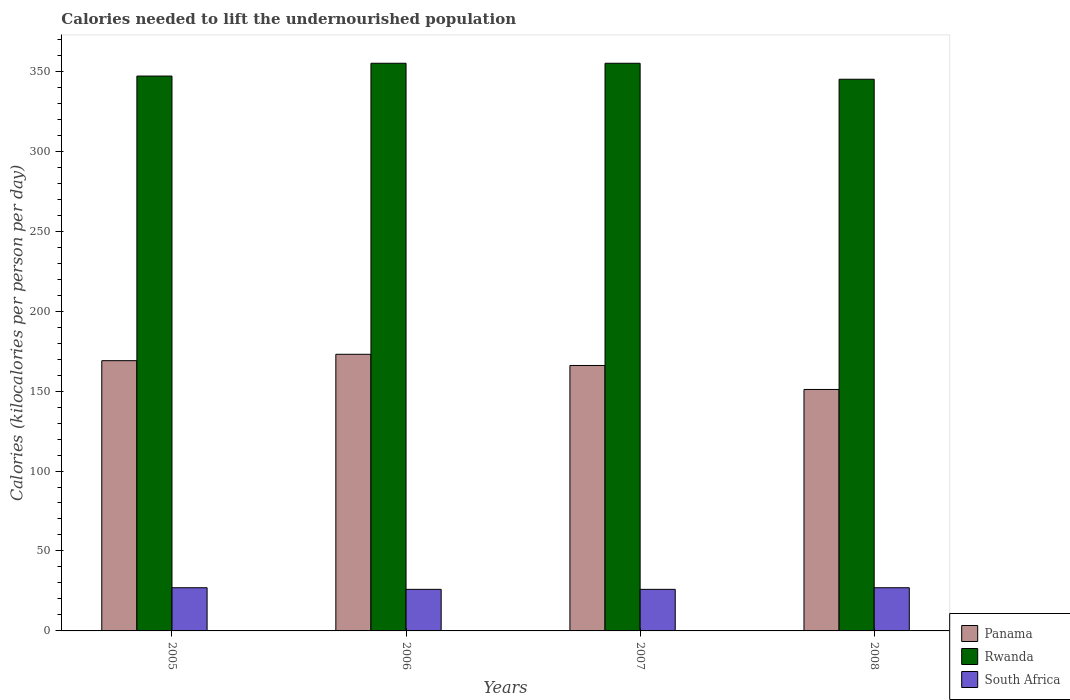How many different coloured bars are there?
Keep it short and to the point. 3. Are the number of bars on each tick of the X-axis equal?
Offer a terse response. Yes. What is the total calories needed to lift the undernourished population in Panama in 2008?
Keep it short and to the point. 151. Across all years, what is the maximum total calories needed to lift the undernourished population in Rwanda?
Keep it short and to the point. 355. Across all years, what is the minimum total calories needed to lift the undernourished population in Rwanda?
Your answer should be compact. 345. In which year was the total calories needed to lift the undernourished population in Rwanda maximum?
Make the answer very short. 2006. What is the total total calories needed to lift the undernourished population in Rwanda in the graph?
Offer a very short reply. 1402. What is the difference between the total calories needed to lift the undernourished population in Rwanda in 2005 and that in 2006?
Make the answer very short. -8. What is the difference between the total calories needed to lift the undernourished population in Panama in 2008 and the total calories needed to lift the undernourished population in Rwanda in 2005?
Your answer should be very brief. -196. What is the average total calories needed to lift the undernourished population in Panama per year?
Make the answer very short. 164.75. In the year 2005, what is the difference between the total calories needed to lift the undernourished population in South Africa and total calories needed to lift the undernourished population in Rwanda?
Offer a terse response. -320. What is the ratio of the total calories needed to lift the undernourished population in South Africa in 2007 to that in 2008?
Provide a short and direct response. 0.96. What is the difference between the highest and the second highest total calories needed to lift the undernourished population in Rwanda?
Offer a very short reply. 0. What is the difference between the highest and the lowest total calories needed to lift the undernourished population in Panama?
Your answer should be very brief. 22. Is the sum of the total calories needed to lift the undernourished population in Panama in 2005 and 2007 greater than the maximum total calories needed to lift the undernourished population in Rwanda across all years?
Keep it short and to the point. No. What does the 2nd bar from the left in 2005 represents?
Give a very brief answer. Rwanda. What does the 2nd bar from the right in 2005 represents?
Ensure brevity in your answer.  Rwanda. Is it the case that in every year, the sum of the total calories needed to lift the undernourished population in Rwanda and total calories needed to lift the undernourished population in Panama is greater than the total calories needed to lift the undernourished population in South Africa?
Keep it short and to the point. Yes. How many bars are there?
Make the answer very short. 12. Are all the bars in the graph horizontal?
Make the answer very short. No. How many years are there in the graph?
Offer a very short reply. 4. What is the difference between two consecutive major ticks on the Y-axis?
Provide a short and direct response. 50. Are the values on the major ticks of Y-axis written in scientific E-notation?
Give a very brief answer. No. Does the graph contain grids?
Offer a very short reply. No. Where does the legend appear in the graph?
Your response must be concise. Bottom right. What is the title of the graph?
Offer a terse response. Calories needed to lift the undernourished population. What is the label or title of the X-axis?
Make the answer very short. Years. What is the label or title of the Y-axis?
Give a very brief answer. Calories (kilocalories per person per day). What is the Calories (kilocalories per person per day) of Panama in 2005?
Keep it short and to the point. 169. What is the Calories (kilocalories per person per day) of Rwanda in 2005?
Make the answer very short. 347. What is the Calories (kilocalories per person per day) in Panama in 2006?
Provide a short and direct response. 173. What is the Calories (kilocalories per person per day) of Rwanda in 2006?
Your answer should be compact. 355. What is the Calories (kilocalories per person per day) in South Africa in 2006?
Ensure brevity in your answer.  26. What is the Calories (kilocalories per person per day) of Panama in 2007?
Your answer should be compact. 166. What is the Calories (kilocalories per person per day) of Rwanda in 2007?
Provide a short and direct response. 355. What is the Calories (kilocalories per person per day) in South Africa in 2007?
Offer a terse response. 26. What is the Calories (kilocalories per person per day) in Panama in 2008?
Offer a terse response. 151. What is the Calories (kilocalories per person per day) of Rwanda in 2008?
Ensure brevity in your answer.  345. What is the Calories (kilocalories per person per day) in South Africa in 2008?
Your answer should be very brief. 27. Across all years, what is the maximum Calories (kilocalories per person per day) of Panama?
Provide a short and direct response. 173. Across all years, what is the maximum Calories (kilocalories per person per day) of Rwanda?
Make the answer very short. 355. Across all years, what is the minimum Calories (kilocalories per person per day) of Panama?
Your answer should be compact. 151. Across all years, what is the minimum Calories (kilocalories per person per day) in Rwanda?
Your response must be concise. 345. Across all years, what is the minimum Calories (kilocalories per person per day) of South Africa?
Offer a very short reply. 26. What is the total Calories (kilocalories per person per day) of Panama in the graph?
Provide a succinct answer. 659. What is the total Calories (kilocalories per person per day) in Rwanda in the graph?
Provide a succinct answer. 1402. What is the total Calories (kilocalories per person per day) of South Africa in the graph?
Keep it short and to the point. 106. What is the difference between the Calories (kilocalories per person per day) of Panama in 2005 and that in 2006?
Make the answer very short. -4. What is the difference between the Calories (kilocalories per person per day) in Rwanda in 2005 and that in 2006?
Offer a very short reply. -8. What is the difference between the Calories (kilocalories per person per day) in Panama in 2005 and that in 2007?
Give a very brief answer. 3. What is the difference between the Calories (kilocalories per person per day) of South Africa in 2005 and that in 2007?
Your answer should be very brief. 1. What is the difference between the Calories (kilocalories per person per day) in South Africa in 2005 and that in 2008?
Your answer should be compact. 0. What is the difference between the Calories (kilocalories per person per day) in Panama in 2006 and that in 2007?
Your answer should be very brief. 7. What is the difference between the Calories (kilocalories per person per day) of South Africa in 2006 and that in 2007?
Provide a short and direct response. 0. What is the difference between the Calories (kilocalories per person per day) in Panama in 2006 and that in 2008?
Keep it short and to the point. 22. What is the difference between the Calories (kilocalories per person per day) of South Africa in 2006 and that in 2008?
Provide a short and direct response. -1. What is the difference between the Calories (kilocalories per person per day) in Panama in 2007 and that in 2008?
Make the answer very short. 15. What is the difference between the Calories (kilocalories per person per day) of Rwanda in 2007 and that in 2008?
Ensure brevity in your answer.  10. What is the difference between the Calories (kilocalories per person per day) in South Africa in 2007 and that in 2008?
Provide a short and direct response. -1. What is the difference between the Calories (kilocalories per person per day) in Panama in 2005 and the Calories (kilocalories per person per day) in Rwanda in 2006?
Your answer should be very brief. -186. What is the difference between the Calories (kilocalories per person per day) in Panama in 2005 and the Calories (kilocalories per person per day) in South Africa in 2006?
Make the answer very short. 143. What is the difference between the Calories (kilocalories per person per day) in Rwanda in 2005 and the Calories (kilocalories per person per day) in South Africa in 2006?
Offer a very short reply. 321. What is the difference between the Calories (kilocalories per person per day) in Panama in 2005 and the Calories (kilocalories per person per day) in Rwanda in 2007?
Keep it short and to the point. -186. What is the difference between the Calories (kilocalories per person per day) in Panama in 2005 and the Calories (kilocalories per person per day) in South Africa in 2007?
Provide a short and direct response. 143. What is the difference between the Calories (kilocalories per person per day) in Rwanda in 2005 and the Calories (kilocalories per person per day) in South Africa in 2007?
Provide a short and direct response. 321. What is the difference between the Calories (kilocalories per person per day) of Panama in 2005 and the Calories (kilocalories per person per day) of Rwanda in 2008?
Provide a short and direct response. -176. What is the difference between the Calories (kilocalories per person per day) of Panama in 2005 and the Calories (kilocalories per person per day) of South Africa in 2008?
Keep it short and to the point. 142. What is the difference between the Calories (kilocalories per person per day) in Rwanda in 2005 and the Calories (kilocalories per person per day) in South Africa in 2008?
Your answer should be compact. 320. What is the difference between the Calories (kilocalories per person per day) in Panama in 2006 and the Calories (kilocalories per person per day) in Rwanda in 2007?
Your answer should be very brief. -182. What is the difference between the Calories (kilocalories per person per day) in Panama in 2006 and the Calories (kilocalories per person per day) in South Africa in 2007?
Your response must be concise. 147. What is the difference between the Calories (kilocalories per person per day) in Rwanda in 2006 and the Calories (kilocalories per person per day) in South Africa in 2007?
Make the answer very short. 329. What is the difference between the Calories (kilocalories per person per day) in Panama in 2006 and the Calories (kilocalories per person per day) in Rwanda in 2008?
Make the answer very short. -172. What is the difference between the Calories (kilocalories per person per day) in Panama in 2006 and the Calories (kilocalories per person per day) in South Africa in 2008?
Your response must be concise. 146. What is the difference between the Calories (kilocalories per person per day) in Rwanda in 2006 and the Calories (kilocalories per person per day) in South Africa in 2008?
Provide a short and direct response. 328. What is the difference between the Calories (kilocalories per person per day) in Panama in 2007 and the Calories (kilocalories per person per day) in Rwanda in 2008?
Make the answer very short. -179. What is the difference between the Calories (kilocalories per person per day) in Panama in 2007 and the Calories (kilocalories per person per day) in South Africa in 2008?
Offer a very short reply. 139. What is the difference between the Calories (kilocalories per person per day) of Rwanda in 2007 and the Calories (kilocalories per person per day) of South Africa in 2008?
Make the answer very short. 328. What is the average Calories (kilocalories per person per day) of Panama per year?
Offer a very short reply. 164.75. What is the average Calories (kilocalories per person per day) in Rwanda per year?
Offer a terse response. 350.5. What is the average Calories (kilocalories per person per day) of South Africa per year?
Offer a very short reply. 26.5. In the year 2005, what is the difference between the Calories (kilocalories per person per day) of Panama and Calories (kilocalories per person per day) of Rwanda?
Your answer should be compact. -178. In the year 2005, what is the difference between the Calories (kilocalories per person per day) in Panama and Calories (kilocalories per person per day) in South Africa?
Offer a terse response. 142. In the year 2005, what is the difference between the Calories (kilocalories per person per day) of Rwanda and Calories (kilocalories per person per day) of South Africa?
Your answer should be very brief. 320. In the year 2006, what is the difference between the Calories (kilocalories per person per day) in Panama and Calories (kilocalories per person per day) in Rwanda?
Offer a very short reply. -182. In the year 2006, what is the difference between the Calories (kilocalories per person per day) of Panama and Calories (kilocalories per person per day) of South Africa?
Provide a succinct answer. 147. In the year 2006, what is the difference between the Calories (kilocalories per person per day) of Rwanda and Calories (kilocalories per person per day) of South Africa?
Keep it short and to the point. 329. In the year 2007, what is the difference between the Calories (kilocalories per person per day) in Panama and Calories (kilocalories per person per day) in Rwanda?
Provide a succinct answer. -189. In the year 2007, what is the difference between the Calories (kilocalories per person per day) of Panama and Calories (kilocalories per person per day) of South Africa?
Ensure brevity in your answer.  140. In the year 2007, what is the difference between the Calories (kilocalories per person per day) in Rwanda and Calories (kilocalories per person per day) in South Africa?
Keep it short and to the point. 329. In the year 2008, what is the difference between the Calories (kilocalories per person per day) of Panama and Calories (kilocalories per person per day) of Rwanda?
Provide a short and direct response. -194. In the year 2008, what is the difference between the Calories (kilocalories per person per day) in Panama and Calories (kilocalories per person per day) in South Africa?
Provide a short and direct response. 124. In the year 2008, what is the difference between the Calories (kilocalories per person per day) of Rwanda and Calories (kilocalories per person per day) of South Africa?
Your answer should be compact. 318. What is the ratio of the Calories (kilocalories per person per day) in Panama in 2005 to that in 2006?
Your answer should be very brief. 0.98. What is the ratio of the Calories (kilocalories per person per day) of Rwanda in 2005 to that in 2006?
Give a very brief answer. 0.98. What is the ratio of the Calories (kilocalories per person per day) of South Africa in 2005 to that in 2006?
Provide a succinct answer. 1.04. What is the ratio of the Calories (kilocalories per person per day) in Panama in 2005 to that in 2007?
Provide a succinct answer. 1.02. What is the ratio of the Calories (kilocalories per person per day) in Rwanda in 2005 to that in 2007?
Make the answer very short. 0.98. What is the ratio of the Calories (kilocalories per person per day) in South Africa in 2005 to that in 2007?
Make the answer very short. 1.04. What is the ratio of the Calories (kilocalories per person per day) of Panama in 2005 to that in 2008?
Provide a succinct answer. 1.12. What is the ratio of the Calories (kilocalories per person per day) of Rwanda in 2005 to that in 2008?
Keep it short and to the point. 1.01. What is the ratio of the Calories (kilocalories per person per day) of Panama in 2006 to that in 2007?
Keep it short and to the point. 1.04. What is the ratio of the Calories (kilocalories per person per day) of South Africa in 2006 to that in 2007?
Offer a terse response. 1. What is the ratio of the Calories (kilocalories per person per day) of Panama in 2006 to that in 2008?
Offer a very short reply. 1.15. What is the ratio of the Calories (kilocalories per person per day) of Panama in 2007 to that in 2008?
Keep it short and to the point. 1.1. What is the ratio of the Calories (kilocalories per person per day) in South Africa in 2007 to that in 2008?
Your response must be concise. 0.96. What is the difference between the highest and the second highest Calories (kilocalories per person per day) of Panama?
Offer a very short reply. 4. What is the difference between the highest and the second highest Calories (kilocalories per person per day) of Rwanda?
Your answer should be compact. 0. What is the difference between the highest and the lowest Calories (kilocalories per person per day) in Panama?
Offer a very short reply. 22. What is the difference between the highest and the lowest Calories (kilocalories per person per day) in Rwanda?
Your answer should be compact. 10. 